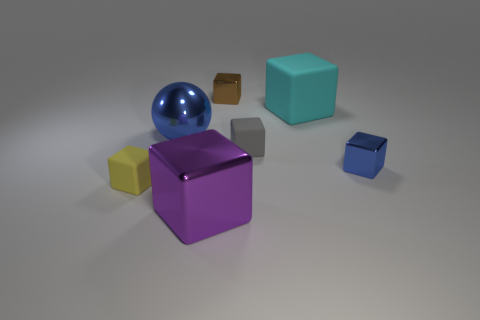Subtract all purple shiny blocks. How many blocks are left? 5 Subtract all yellow blocks. How many blocks are left? 5 Subtract all cyan blocks. Subtract all cyan spheres. How many blocks are left? 5 Add 1 big purple metal things. How many objects exist? 8 Subtract all balls. How many objects are left? 6 Add 5 large cyan matte things. How many large cyan matte things exist? 6 Subtract 0 green spheres. How many objects are left? 7 Subtract all small purple rubber balls. Subtract all small yellow blocks. How many objects are left? 6 Add 4 gray blocks. How many gray blocks are left? 5 